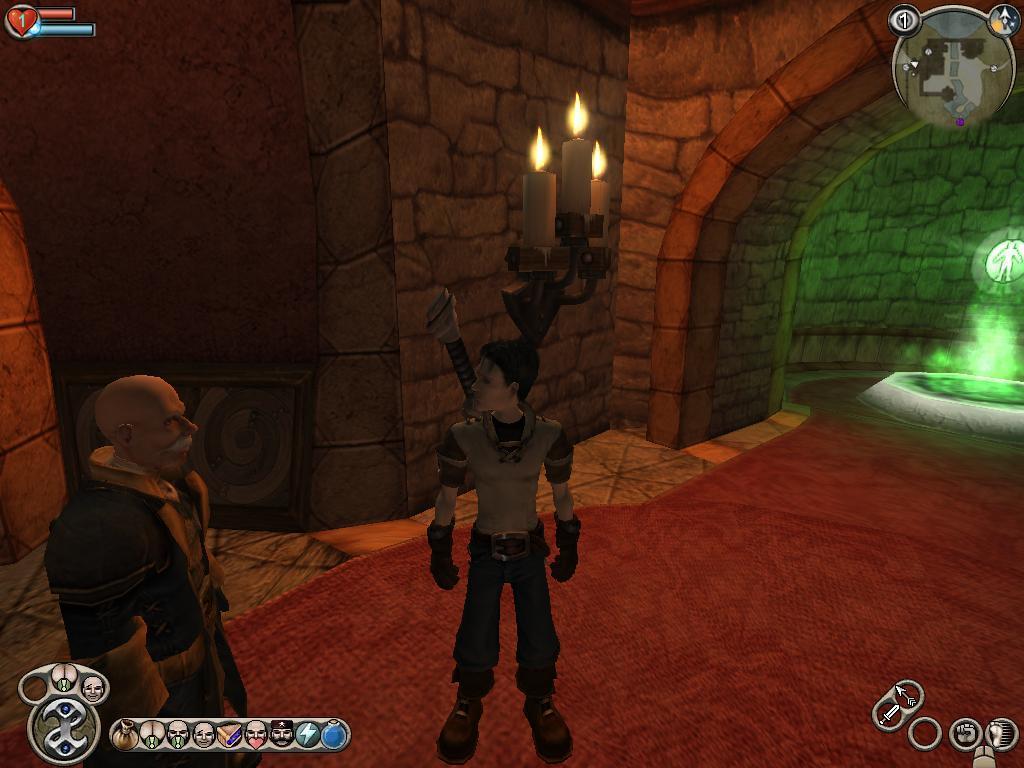Please provide a concise description of this image. This image is an animation. In the center of the image we can see two people. At the bottom there is a carpet. In the background there is a light and we can see candles. 